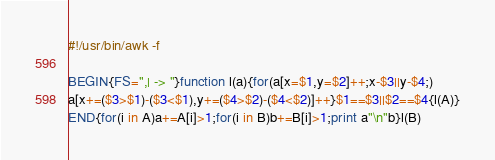Convert code to text. <code><loc_0><loc_0><loc_500><loc_500><_Awk_>#!/usr/bin/awk -f

BEGIN{FS=",| -> "}function l(a){for(a[x=$1,y=$2]++;x-$3||y-$4;)
a[x+=($3>$1)-($3<$1),y+=($4>$2)-($4<$2)]++}$1==$3||$2==$4{l(A)}
END{for(i in A)a+=A[i]>1;for(i in B)b+=B[i]>1;print a"\n"b}l(B)
</code> 